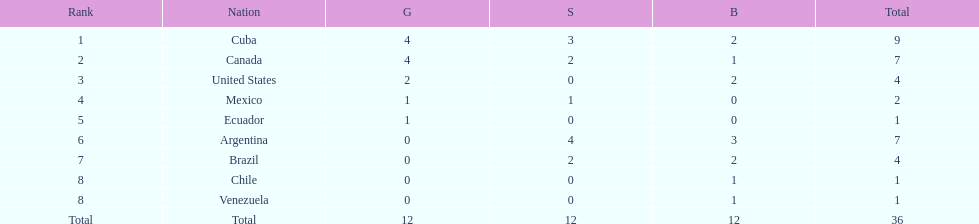Could you parse the entire table? {'header': ['Rank', 'Nation', 'G', 'S', 'B', 'Total'], 'rows': [['1', 'Cuba', '4', '3', '2', '9'], ['2', 'Canada', '4', '2', '1', '7'], ['3', 'United States', '2', '0', '2', '4'], ['4', 'Mexico', '1', '1', '0', '2'], ['5', 'Ecuador', '1', '0', '0', '1'], ['6', 'Argentina', '0', '4', '3', '7'], ['7', 'Brazil', '0', '2', '2', '4'], ['8', 'Chile', '0', '0', '1', '1'], ['8', 'Venezuela', '0', '0', '1', '1'], ['Total', 'Total', '12', '12', '12', '36']]} How many total medals did brazil received? 4. 